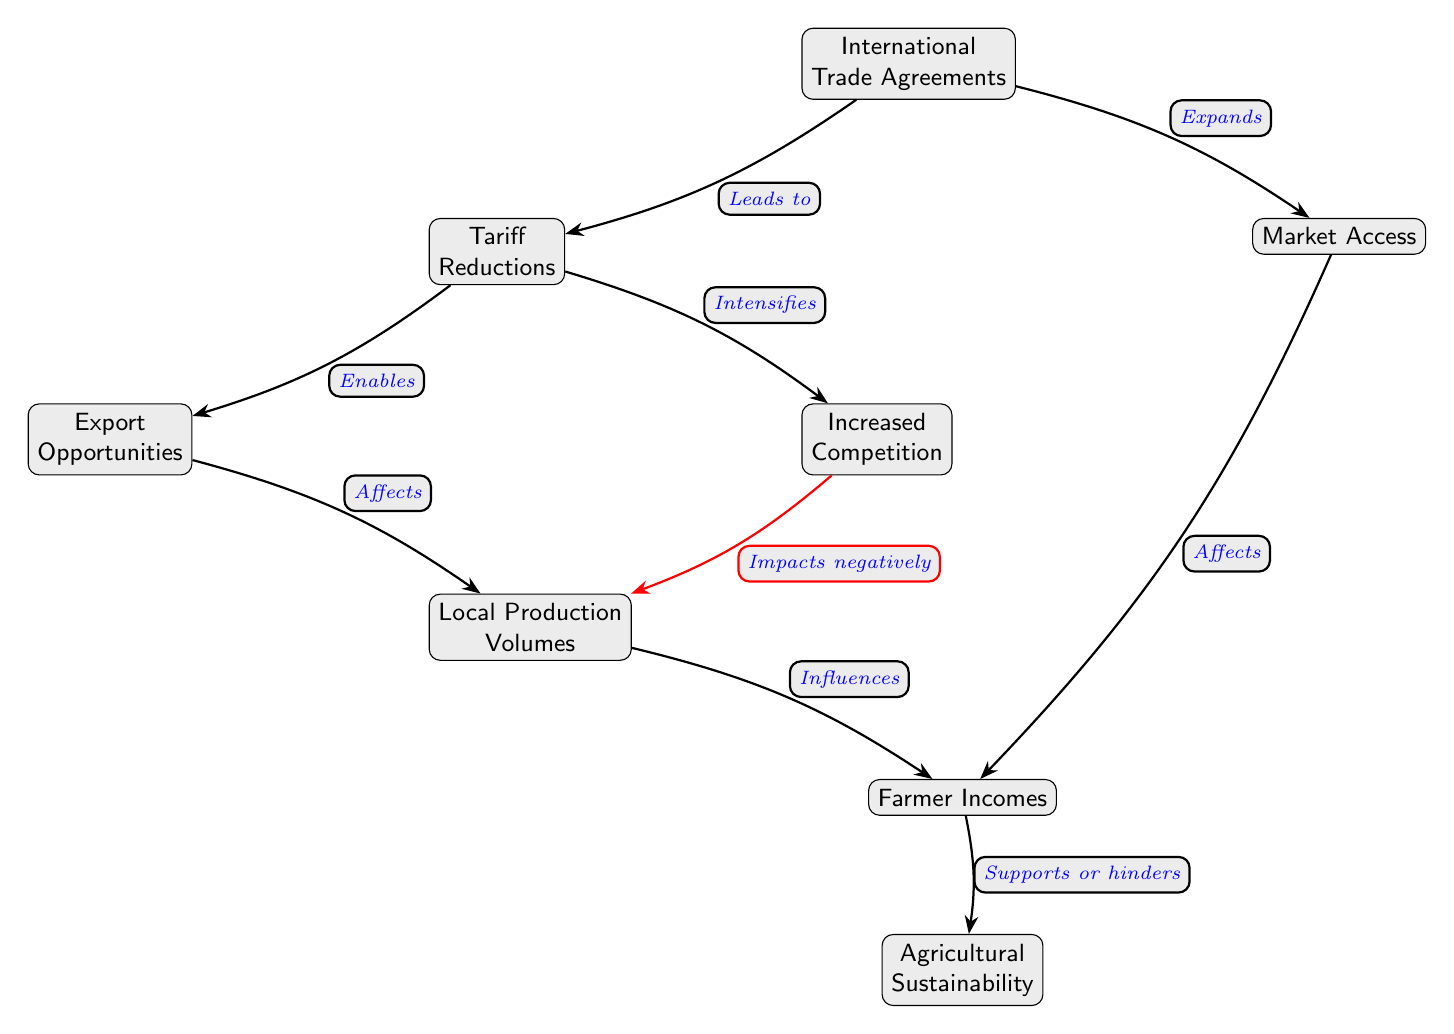What are the two main factors affected by Tariff Reductions? According to the diagram, Tariff Reductions lead to Export Opportunities and Increased Competition as they are directly connected to it with a "Enables" and "Intensifies" edge respectively.
Answer: Export Opportunities, Increased Competition How many nodes are in the diagram? The diagram contains a total of 8 nodes, which represent different concepts related to the impact of International Trade Agreements on agricultural sectors.
Answer: 8 What does Increased Competition negatively impact? The diagram shows that Increased Competition has a direct negative impact on Local Production Volumes, as indicated by the "Impacts negatively" edge connecting these two nodes.
Answer: Local Production Volumes Which node has the direct influence on Farmer Incomes? Farmer Incomes are influenced by Local Production Volumes and Market Access, both of which have edges leading to the Farmer Incomes node indicating their effects, hence it’s either of these.
Answer: Local Production Volumes, Market Access How does Market Access affect Farmer Incomes? The diagram indicates a direct edge from Market Access to Farmer Incomes labeled "Affects", meaning that changes in Market Access have a direct impact on Farmer Incomes.
Answer: Affects What leads to Agricultural Sustainability? The diagram shows that Agricultural Sustainability is supported or hindered by Farmer Incomes, suggesting this is the node that directly influences Agricultural Sustainability.
Answer: Farmer Incomes What is the relationship between International Trade Agreements and Market Access? There is a direct connection from International Trade Agreements to Market Access labeled "Expands", showing that Trade Agreements have a role in enhancing Market Access.
Answer: Expands What does Local Production Volumes influence? According to the diagram, Local Production Volumes directly influence Farmer Incomes, indicating that increases or decreases in production will affect farmers' earnings.
Answer: Farmer Incomes What kind of trade opportunities arise from Tariff Reductions? The diagram indicates that Export Opportunities arise from Tariff Reductions, reflecting the enablement of better export conditions due to reduced tariffs.
Answer: Export Opportunities 